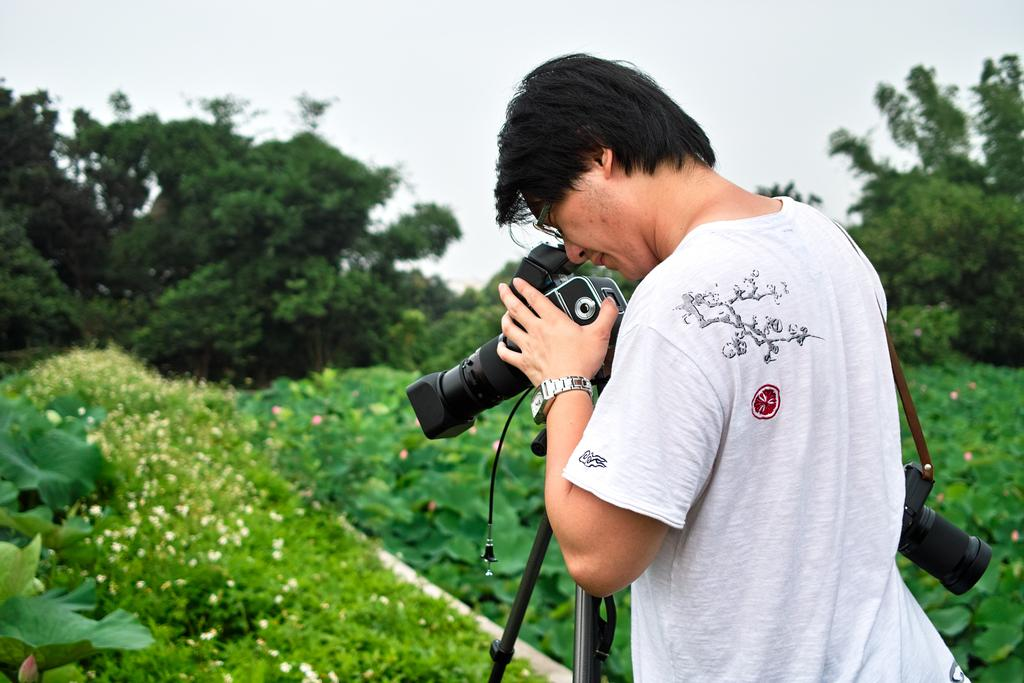What is the main subject of the image? The main subject of the image is a man. What accessories is the man wearing? The man is wearing glasses (specs) and a watch. What is the man holding in the image? The man is holding a camera on a stand and another camera in his hands. What can be seen in the background of the image? There are plants, trees, and the sky visible in the background of the image. What type of blade is the man using to cut the trees in the image? There is no blade or tree-cutting activity depicted in the image; the man is holding cameras and there are trees in the background. What type of beast is the man trying to tame in the image? There is no beast present in the image; the man is holding cameras and there are trees in the background. 